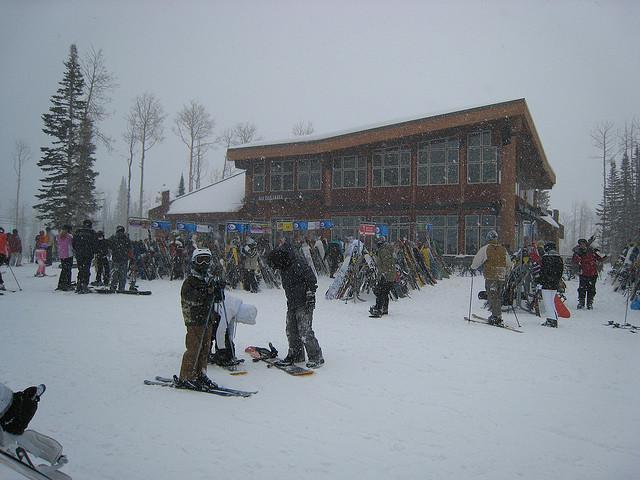Which weather phenomenon is likely to be most frustrating to people seen here at this place?
From the following four choices, select the correct answer to address the question.
Options: Hard freeze, snow, heat wave, cool wind. Heat wave. 